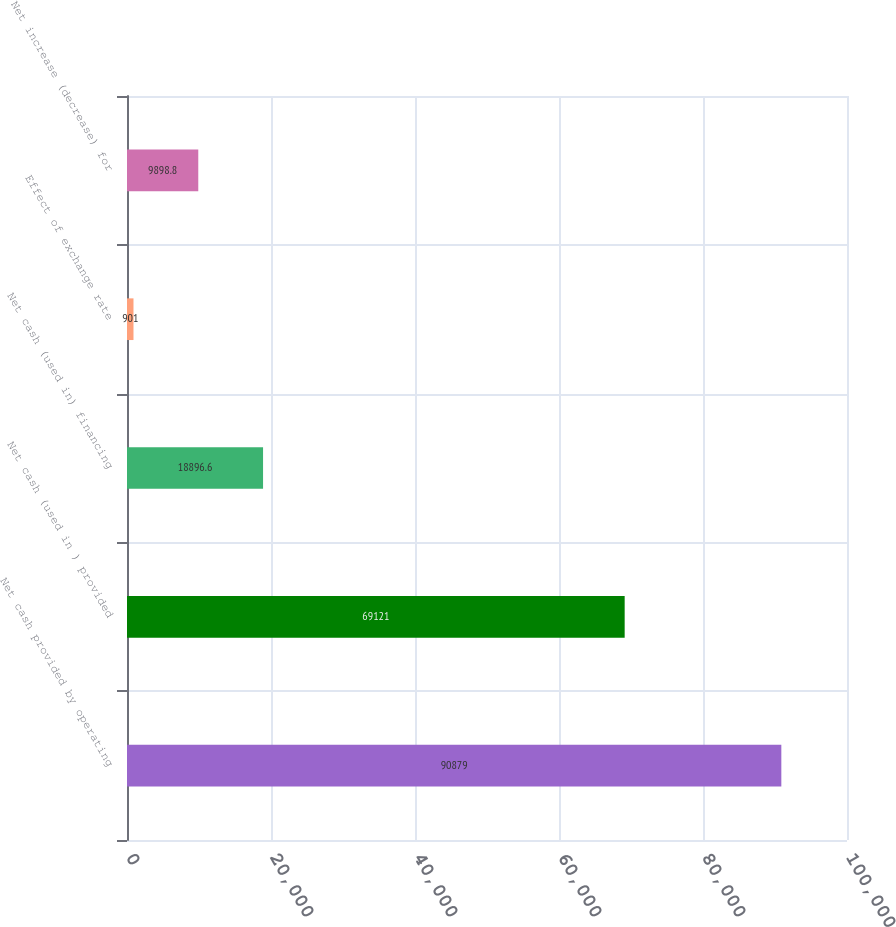Convert chart to OTSL. <chart><loc_0><loc_0><loc_500><loc_500><bar_chart><fcel>Net cash provided by operating<fcel>Net cash (used in ) provided<fcel>Net cash (used in) financing<fcel>Effect of exchange rate<fcel>Net increase (decrease) for<nl><fcel>90879<fcel>69121<fcel>18896.6<fcel>901<fcel>9898.8<nl></chart> 